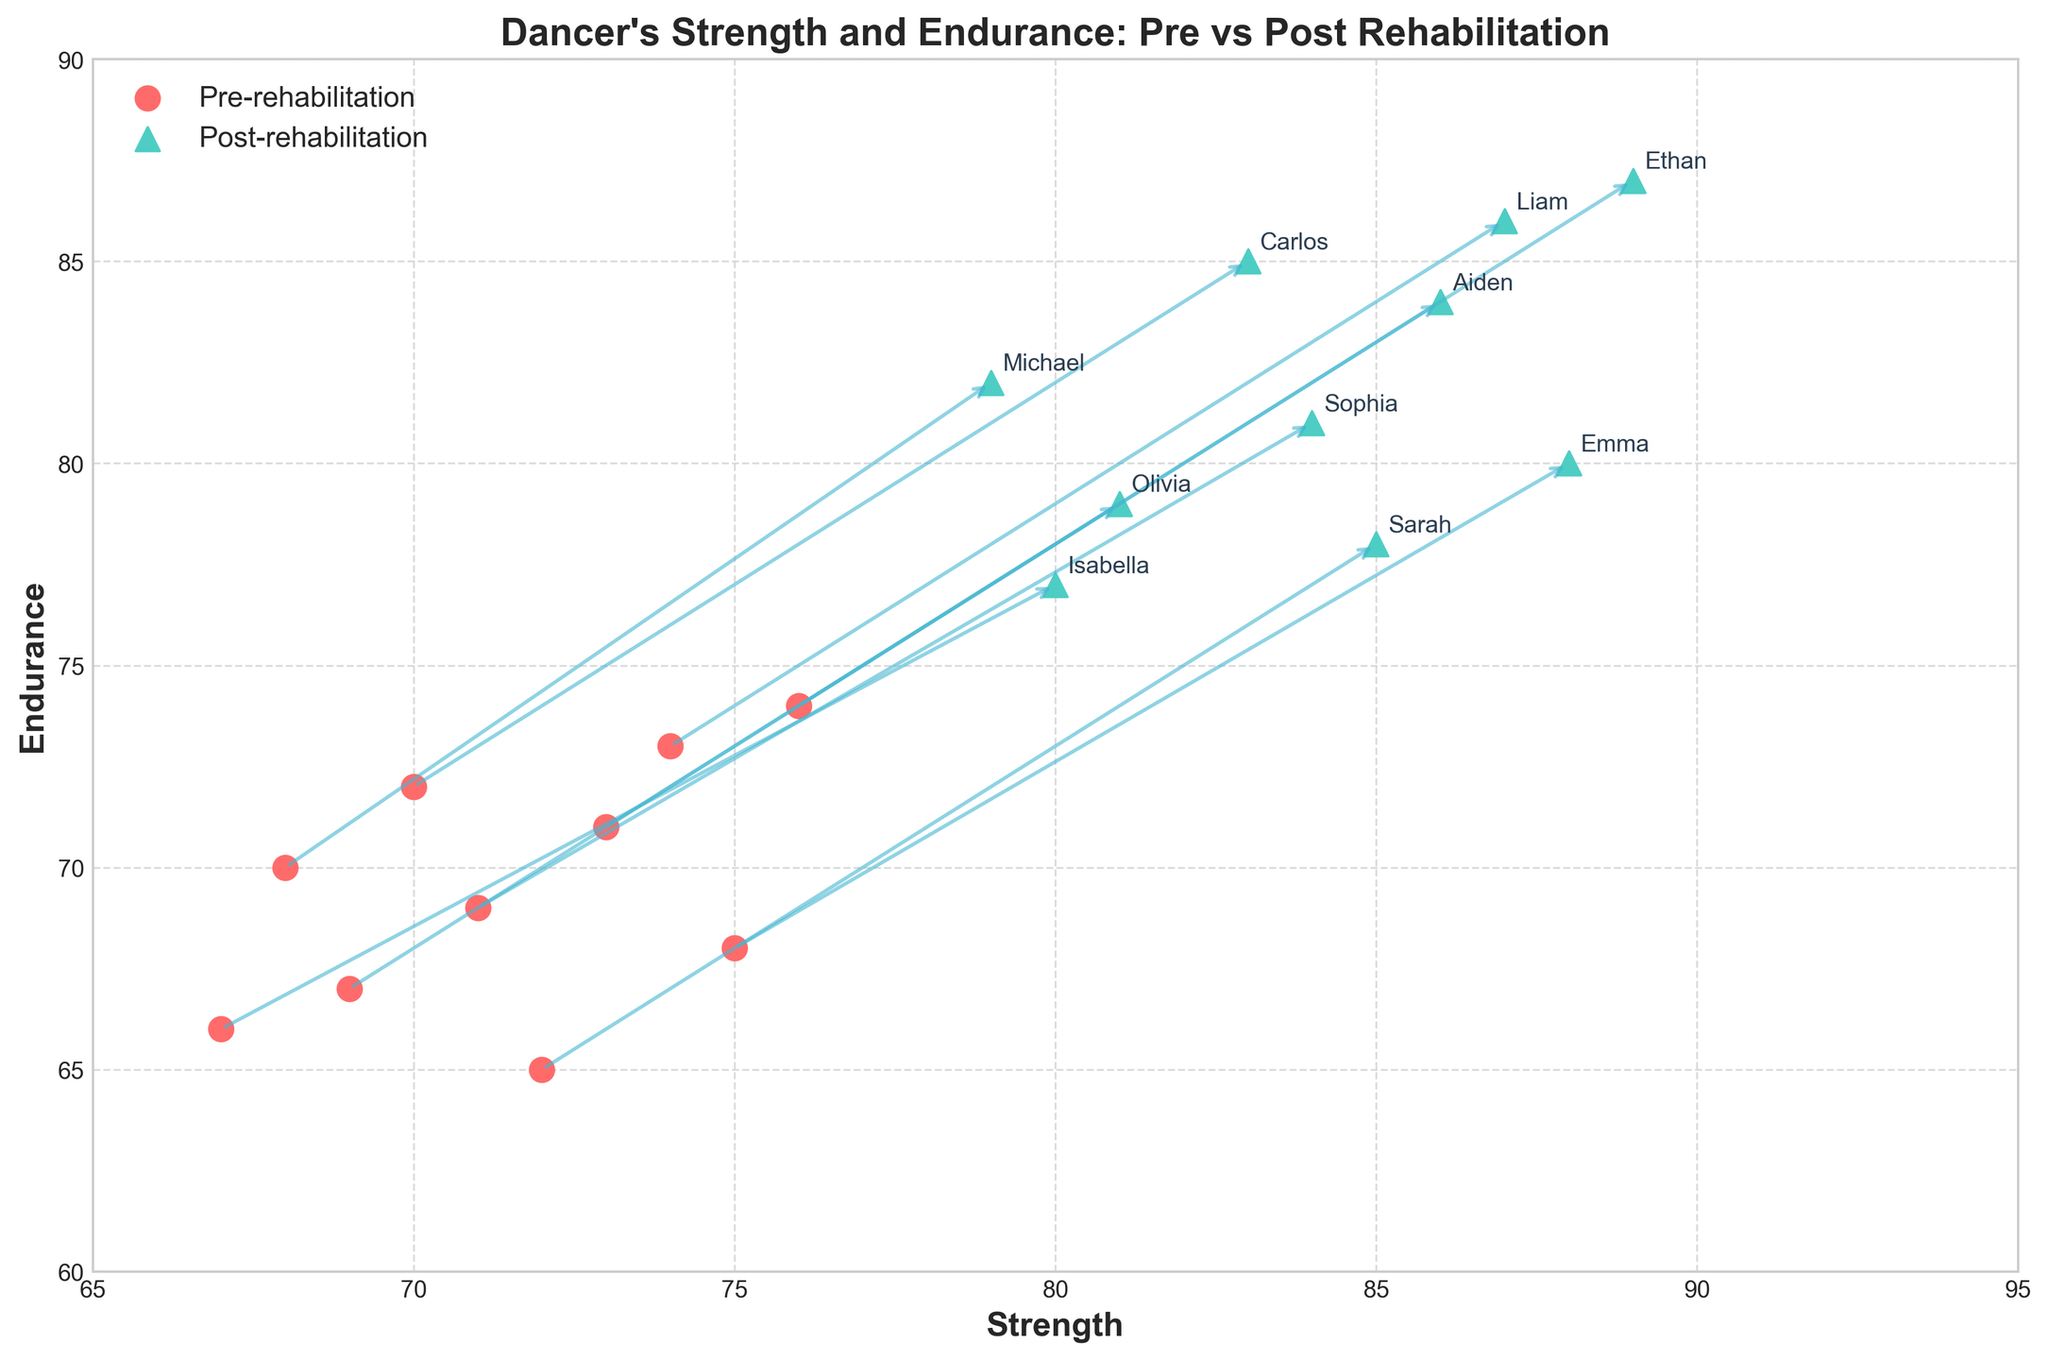How many data points are displayed in the figure? The figure tracks the strength and endurance of 10 dancers, both pre- and post-rehabilitation. Each dancer has one pre-rehabilitation and one post-rehabilitation data point. There are a total of 20 data points.
Answer: 20 What is the title of the figure? The title is located at the top of the chart and describes the overall content as it generally does in a graph. It reads "Dancer's Strength and Endurance: Pre vs Post Rehabilitation".
Answer: Dancer's Strength and Endurance: Pre vs Post Rehabilitation Which axes represent strength and endurance? By looking at their labels, the x-axis is labeled "Strength" and the y-axis is labeled "Endurance".
Answer: x-axis: Strength, y-axis: Endurance Which dancer showed the highest post-rehabilitation strength? The post-rehabilitation strength is represented by upward-facing triangles. The dancer with the highest post-rehabilitation strength is marked at 89. The label "Ethan" confirms this.
Answer: Ethan Are there any dancers whose strength did not improve post-rehabilitation? Observing the arrows from pre- to post-rehabilitation for each dancer, all arrows point to the right, indicating an increase in strength for all dancers.
Answer: No What general trend can you observe for endurance in this biplot? All arrows indicating the change from pre- to post-rehabilitation point upwards, which suggests that the endurance of all dancers improved.
Answer: Endurance improved for all dancers Which dancer showed the greatest improvement in endurance? Compare the vertical lengths of the arrows. Ethan shows the greatest vertical distance, indicating the largest improvement in endurance.
Answer: Ethan Is there a correlation between pre-rehabilitation strength and post-rehabilitation endurance? By examining the scatter plot points for pre and post-rehabilitation, there's a visible trend indicating that dancers with higher initial strength tend to exhibit higher endurance post-rehabilitation as well, though individual differences exist.
Answer: Yes, there seems to be a positive correlation What is the approximate average post-rehabilitation strength? Examine the post-rehabilitation strength values: (85+79+88+83+81+86+84+87+80+89). Sum them (842) and divide by 10 (the number of dancers). This yields an average post-rehabilitation strength of about 84.2.
Answer: 84.2 Compare Sarah and Michael's post-rehabilitation endurance. Sarah’s post-rehabilitation endurance is marked as 78, whereas Michael’s post-rehabilitation endurance is marked as 82. Thus, Michael has a higher post-rehabilitation endurance.
Answer: Michael's endurance is higher 